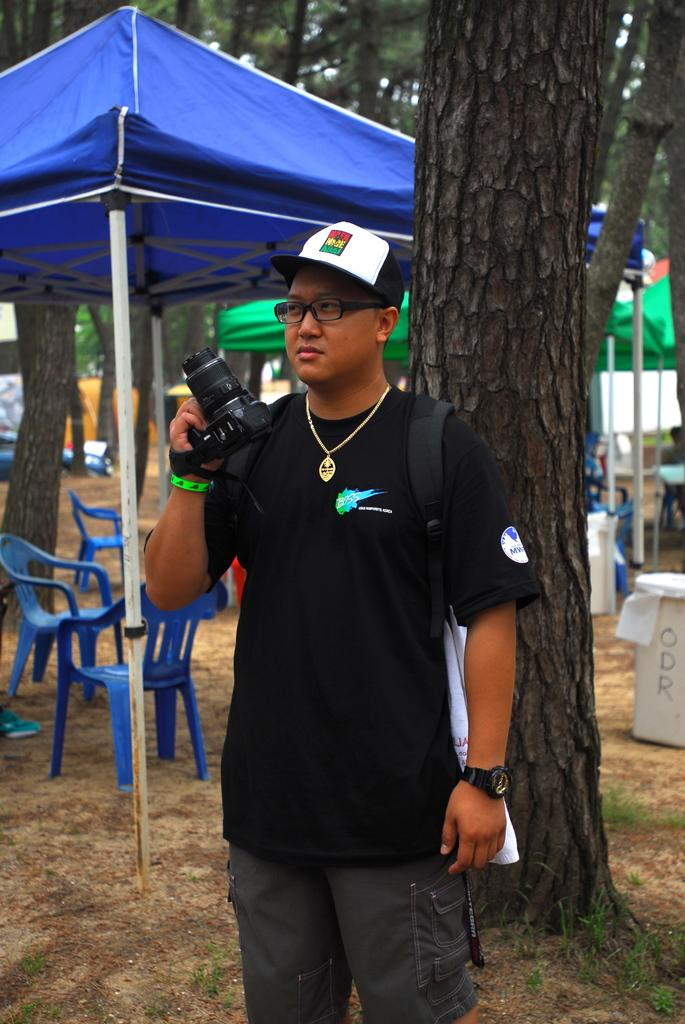What is the person in the image doing? The person is standing in the image and holding a camera. What else can be seen in the image besides the person? Chairs, canopy tents, trees, and objects on the ground are visible in the image. What might the person be using the camera for? The person might be taking photos or recording a video. How many canopy tents are present in the image? There are canopy tents present in the image. What type of ant can be seen crawling on the person's shoulder in the image? There are no ants present in the image; the person is holding a camera and standing near chairs, canopy tents, trees, and objects on the ground. What day of the week is it in the image? The day of the week is not visible or mentioned in the image. 